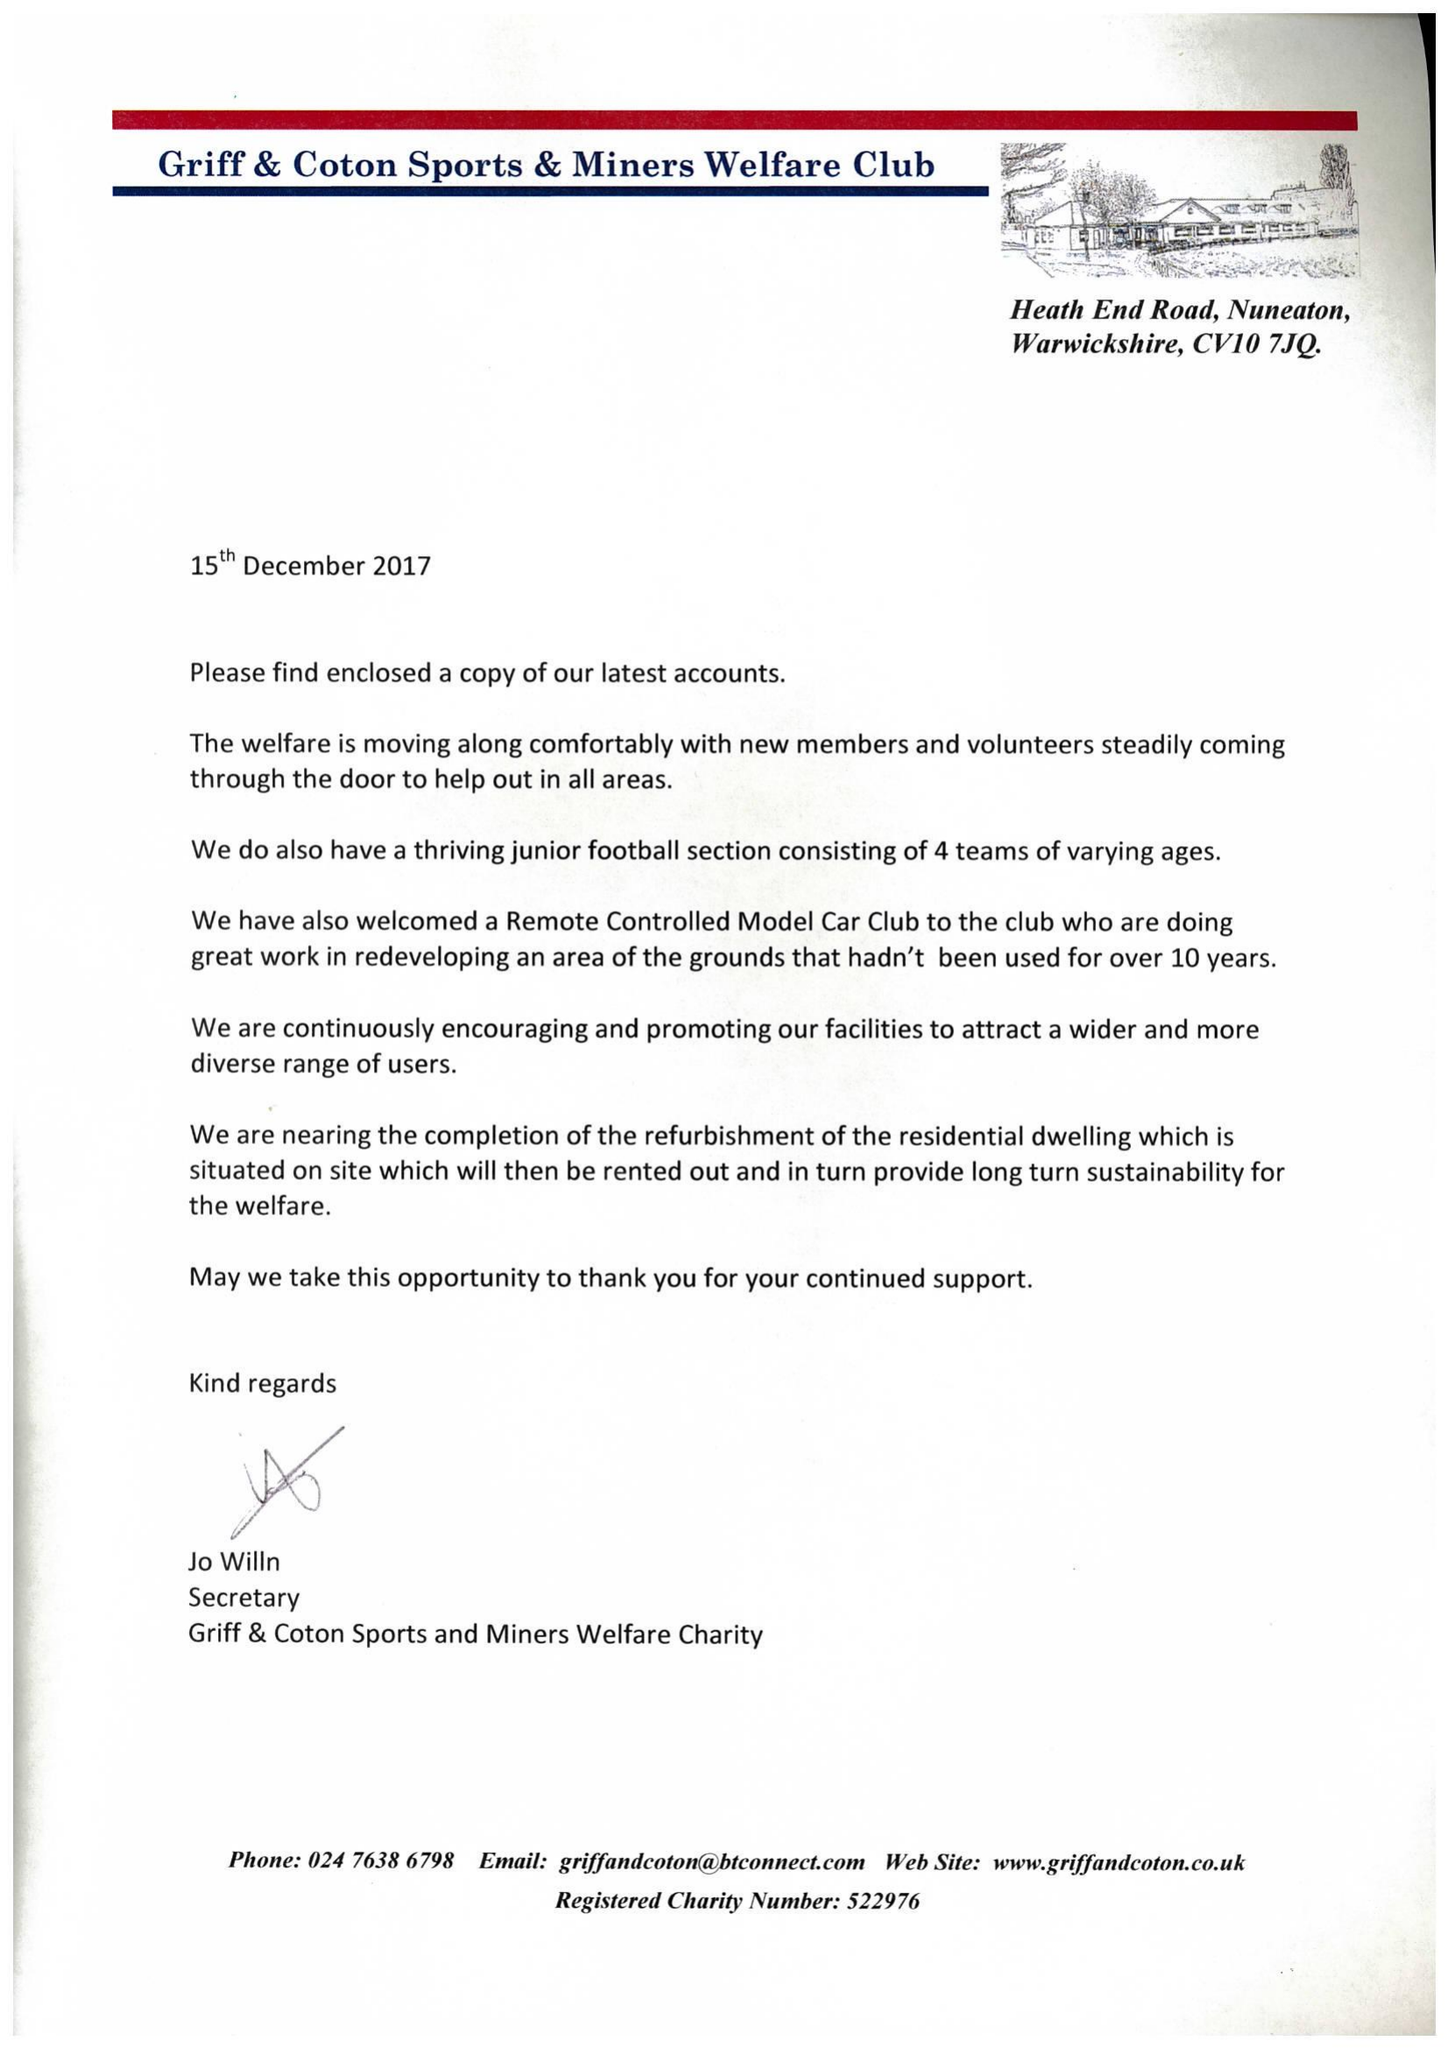What is the value for the report_date?
Answer the question using a single word or phrase. 2016-12-31 